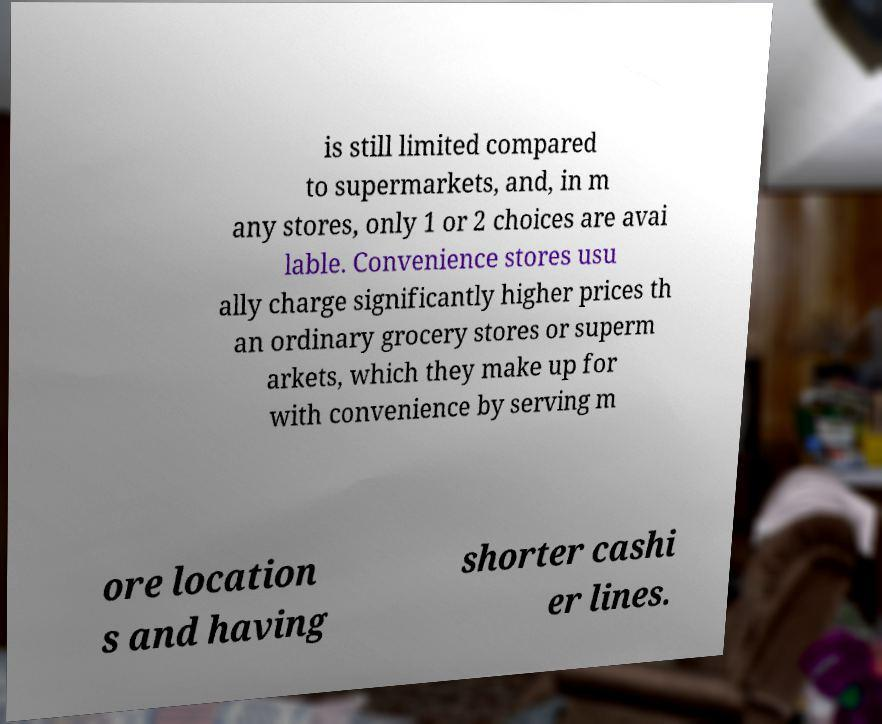There's text embedded in this image that I need extracted. Can you transcribe it verbatim? is still limited compared to supermarkets, and, in m any stores, only 1 or 2 choices are avai lable. Convenience stores usu ally charge significantly higher prices th an ordinary grocery stores or superm arkets, which they make up for with convenience by serving m ore location s and having shorter cashi er lines. 